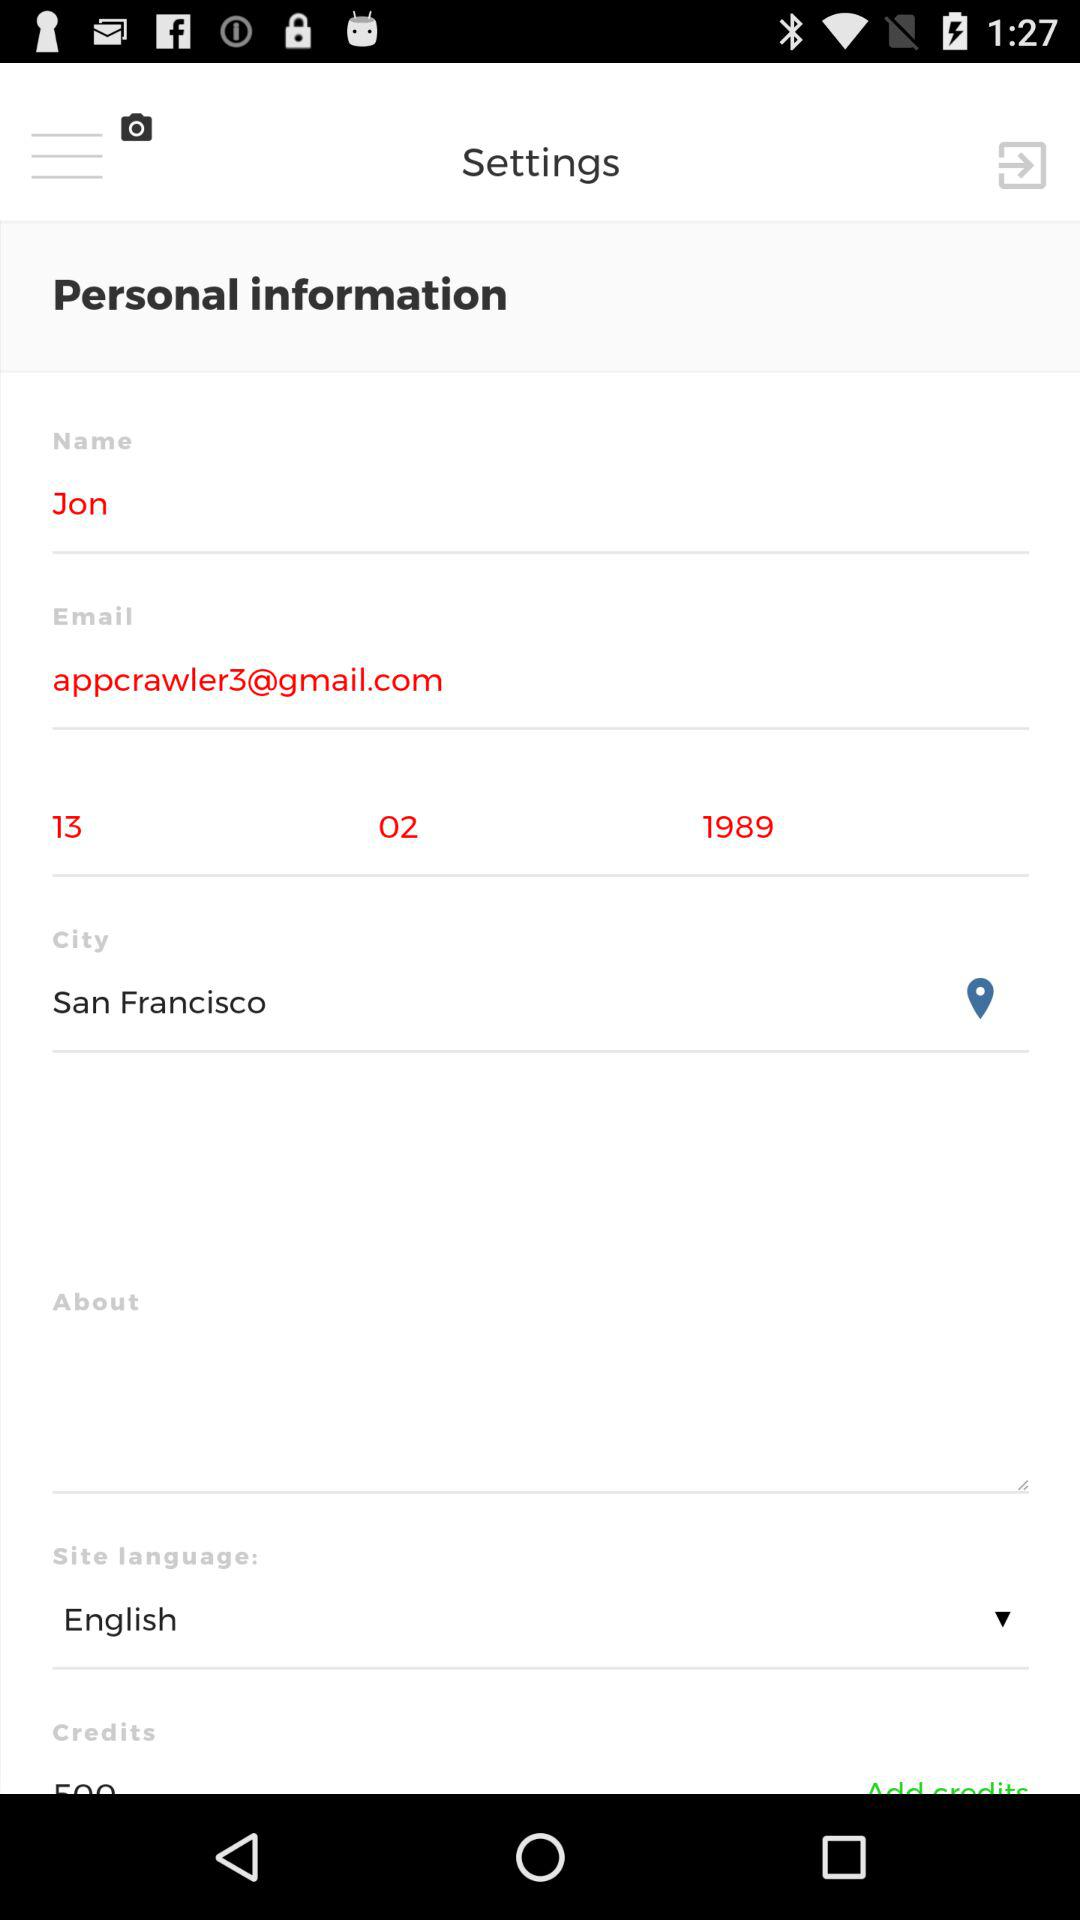How many text inputs have an email address in them?
Answer the question using a single word or phrase. 1 